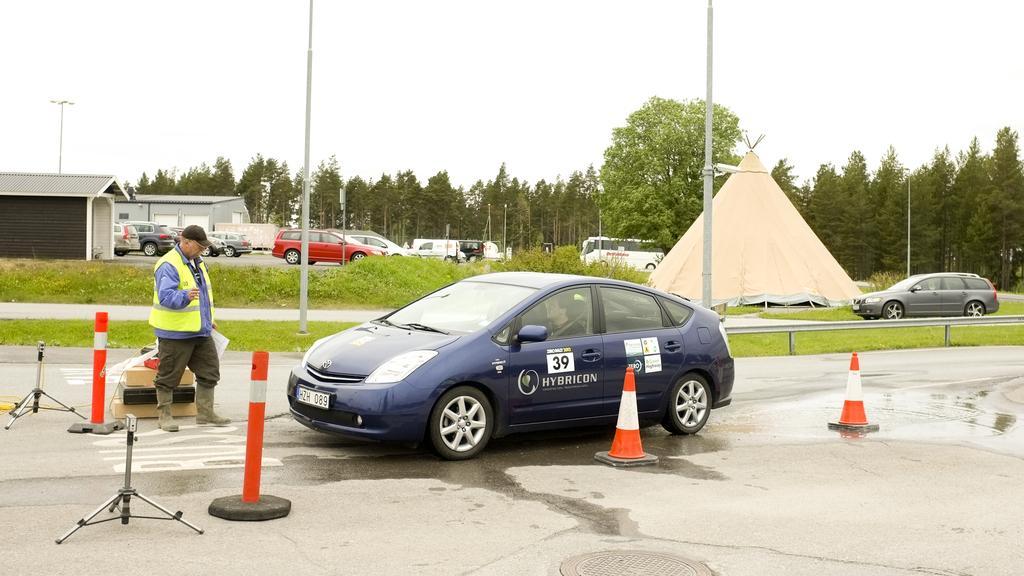In one or two sentences, can you explain what this image depicts? Here in the front we can see a car present on the road over there and in front of it we can see a person standing with a apron and a cap on him and we can also see traffic cones and poles present around the car over there and beside that we can see some part of ground is fully covered with grass over there and we can also see other cars present on the road over there and on the right side we can see a tent present and on the left side we can see sheds present over there and we can also see poles present here and there and we can see plants and trees present all over there. 